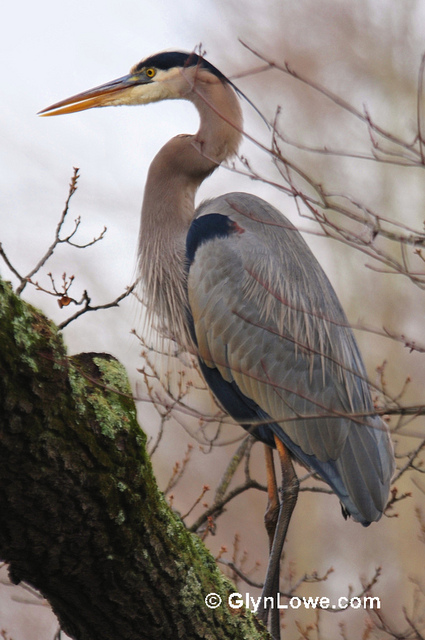Read and extract the text from this image. Glyn .com Lowe 